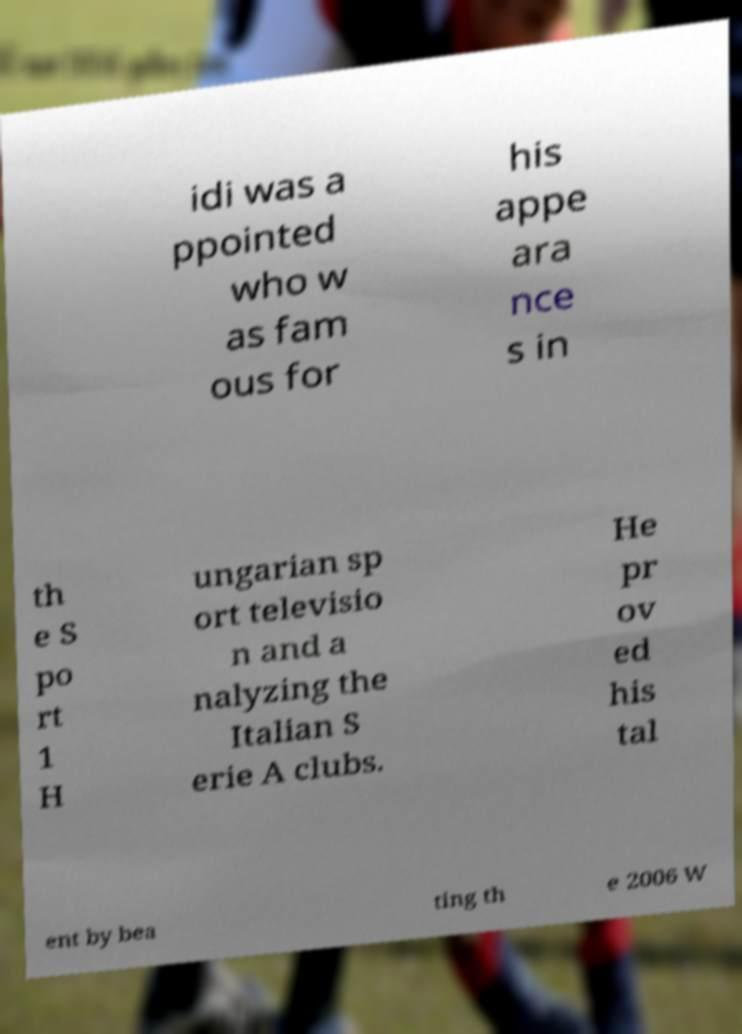Please read and relay the text visible in this image. What does it say? idi was a ppointed who w as fam ous for his appe ara nce s in th e S po rt 1 H ungarian sp ort televisio n and a nalyzing the Italian S erie A clubs. He pr ov ed his tal ent by bea ting th e 2006 W 